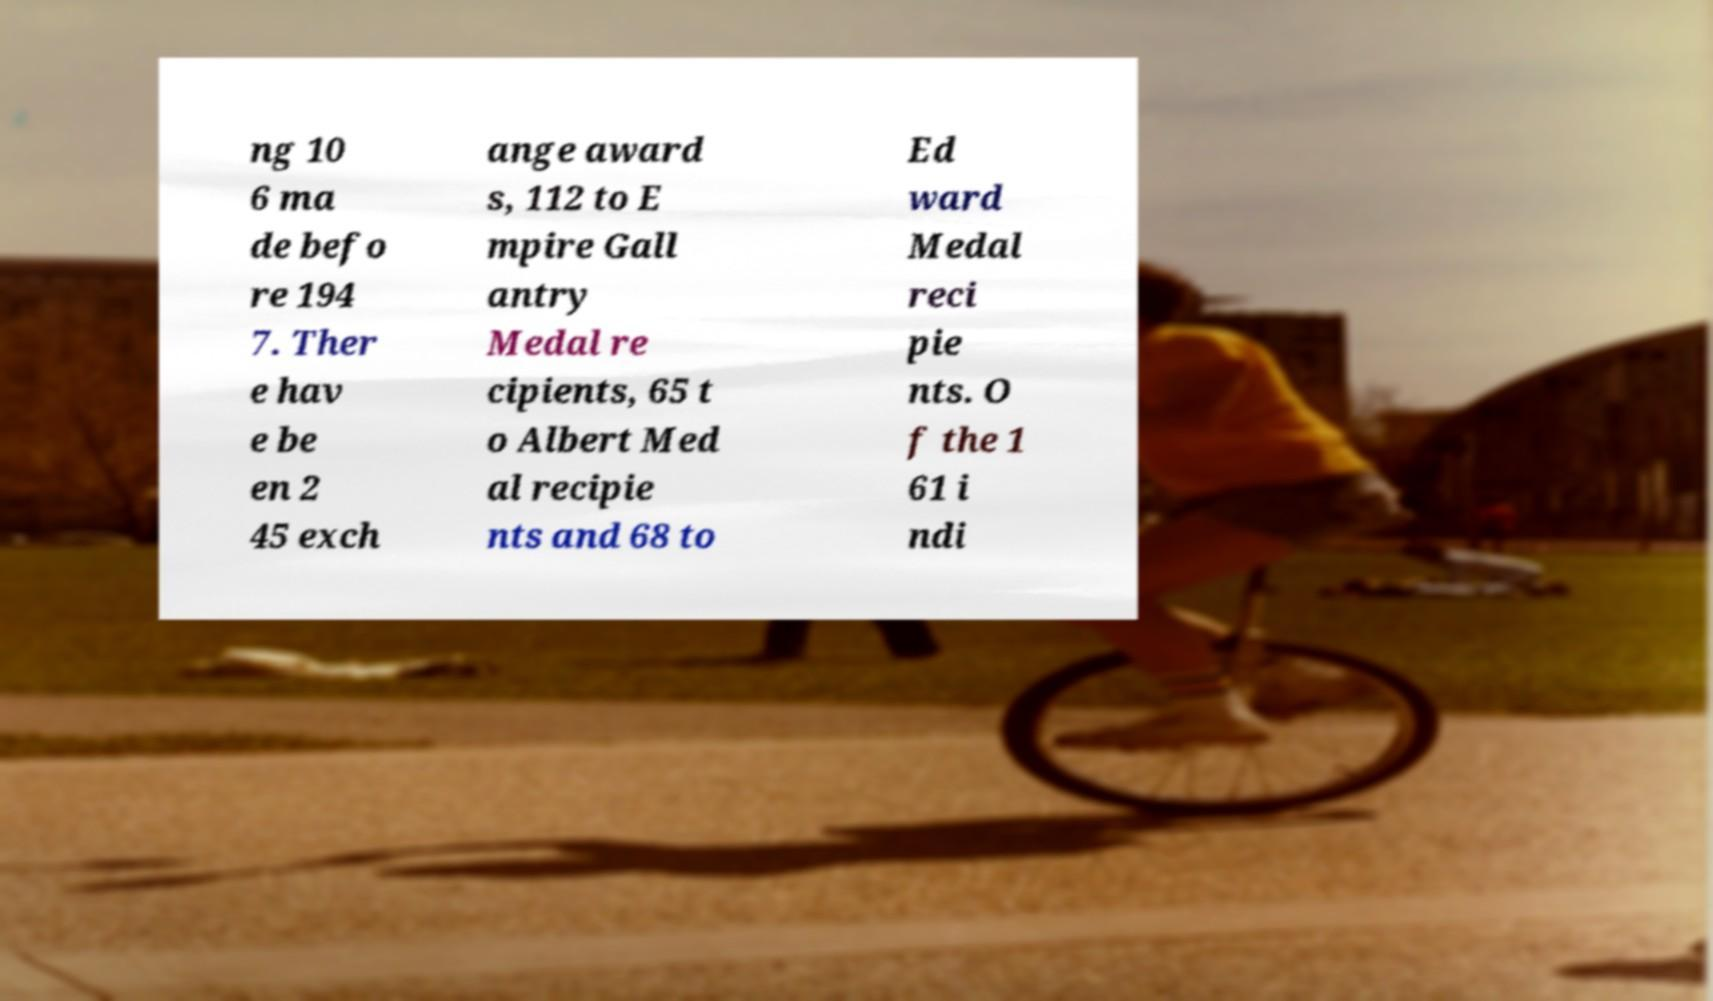Please read and relay the text visible in this image. What does it say? ng 10 6 ma de befo re 194 7. Ther e hav e be en 2 45 exch ange award s, 112 to E mpire Gall antry Medal re cipients, 65 t o Albert Med al recipie nts and 68 to Ed ward Medal reci pie nts. O f the 1 61 i ndi 